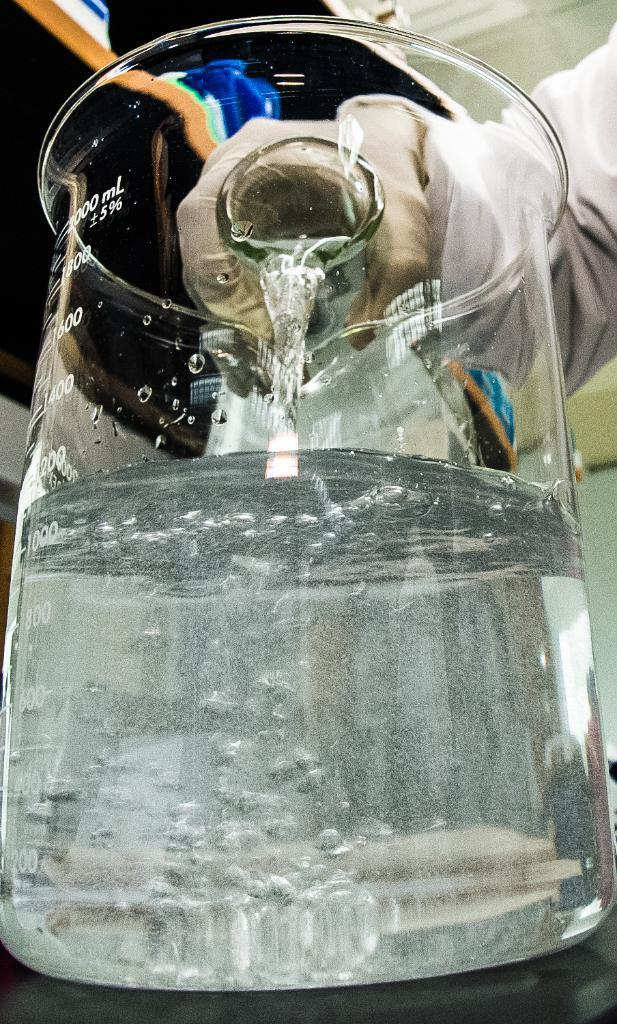What is located in the center of the image? There is a human hand and a test tube in the center of the image. What is inside the test tube? The test tube contains a solution. What type of pickle is being ploughed in the image? There is no pickle or plough present in the image. What type of bushes can be seen growing around the test tube? There are no bushes present in the image; the focus is on the human hand and the test tube. 